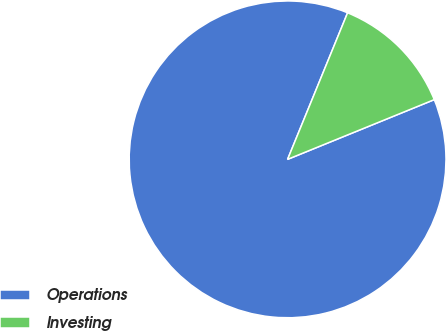Convert chart. <chart><loc_0><loc_0><loc_500><loc_500><pie_chart><fcel>Operations<fcel>Investing<nl><fcel>87.34%<fcel>12.66%<nl></chart> 